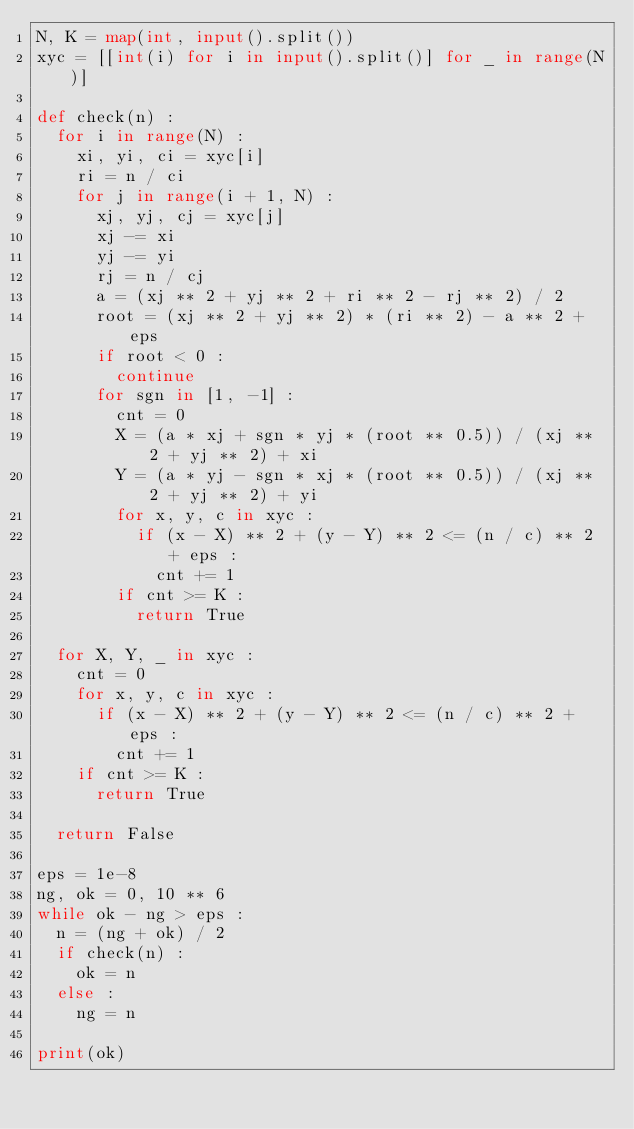<code> <loc_0><loc_0><loc_500><loc_500><_Python_>N, K = map(int, input().split())
xyc = [[int(i) for i in input().split()] for _ in range(N)]

def check(n) :
  for i in range(N) :
    xi, yi, ci = xyc[i]
    ri = n / ci
    for j in range(i + 1, N) :
      xj, yj, cj = xyc[j]
      xj -= xi
      yj -= yi
      rj = n / cj
      a = (xj ** 2 + yj ** 2 + ri ** 2 - rj ** 2) / 2
      root = (xj ** 2 + yj ** 2) * (ri ** 2) - a ** 2 + eps
      if root < 0 : 
        continue
      for sgn in [1, -1] :
        cnt = 0
        X = (a * xj + sgn * yj * (root ** 0.5)) / (xj ** 2 + yj ** 2) + xi
        Y = (a * yj - sgn * xj * (root ** 0.5)) / (xj ** 2 + yj ** 2) + yi
        for x, y, c in xyc :
          if (x - X) ** 2 + (y - Y) ** 2 <= (n / c) ** 2 + eps :
            cnt += 1
        if cnt >= K :
          return True
  
  for X, Y, _ in xyc :
    cnt = 0
    for x, y, c in xyc :
      if (x - X) ** 2 + (y - Y) ** 2 <= (n / c) ** 2 + eps :
        cnt += 1
    if cnt >= K :
      return True
      
  return False

eps = 1e-8
ng, ok = 0, 10 ** 6
while ok - ng > eps :
  n = (ng + ok) / 2
  if check(n) :
    ok = n
  else :
    ng = n
 
print(ok)</code> 